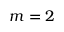<formula> <loc_0><loc_0><loc_500><loc_500>m = 2</formula> 